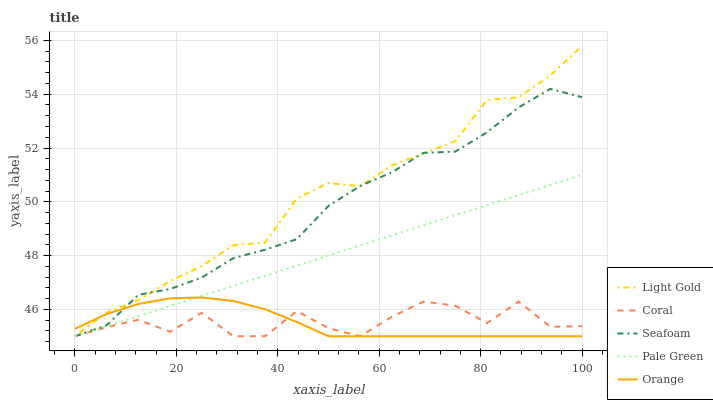Does Orange have the minimum area under the curve?
Answer yes or no. Yes. Does Light Gold have the maximum area under the curve?
Answer yes or no. Yes. Does Coral have the minimum area under the curve?
Answer yes or no. No. Does Coral have the maximum area under the curve?
Answer yes or no. No. Is Pale Green the smoothest?
Answer yes or no. Yes. Is Coral the roughest?
Answer yes or no. Yes. Is Coral the smoothest?
Answer yes or no. No. Is Pale Green the roughest?
Answer yes or no. No. Does Orange have the lowest value?
Answer yes or no. Yes. Does Light Gold have the highest value?
Answer yes or no. Yes. Does Pale Green have the highest value?
Answer yes or no. No. Does Light Gold intersect Seafoam?
Answer yes or no. Yes. Is Light Gold less than Seafoam?
Answer yes or no. No. Is Light Gold greater than Seafoam?
Answer yes or no. No. 